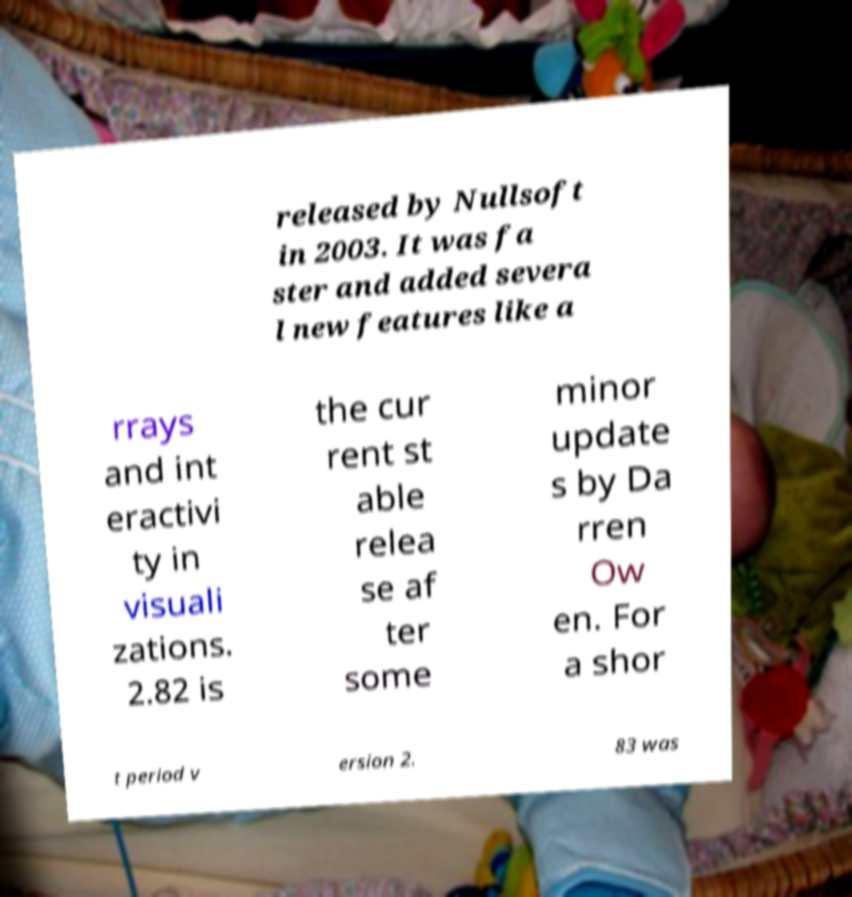I need the written content from this picture converted into text. Can you do that? released by Nullsoft in 2003. It was fa ster and added severa l new features like a rrays and int eractivi ty in visuali zations. 2.82 is the cur rent st able relea se af ter some minor update s by Da rren Ow en. For a shor t period v ersion 2. 83 was 